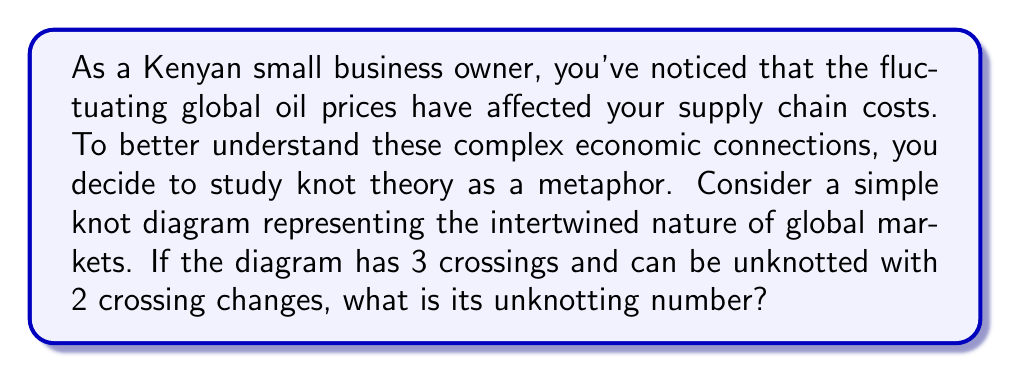Help me with this question. To solve this problem, we need to understand the concept of unknotting number and how it relates to the given knot diagram. Let's break it down step-by-step:

1. Definition of unknotting number:
   The unknotting number of a knot is the minimum number of crossing changes required to transform the knot into an unknot (trivial knot).

2. Given information:
   - The knot diagram has 3 crossings
   - It can be unknotted with 2 crossing changes

3. Analysis:
   - The unknotting number is always less than or equal to the number of crossings in the diagram.
   - In this case, we are told that 2 crossing changes are sufficient to unknot the diagram.
   - The question asks for the unknotting number, which is the minimum number of crossing changes needed.

4. Conclusion:
   Since we know that 2 crossing changes are sufficient to unknot the diagram, and we're looking for the minimum number, the unknotting number must be less than or equal to 2.

   Given that the knot is not trivial (it has 3 crossings), the unknotting number cannot be 0.

   If the unknotting number were 1, it would mean that changing just one crossing would unknot the diagram. However, we're told that 2 changes are needed.

   Therefore, the unknotting number of this knot diagram is 2.

This can be represented mathematically as:

$$u(K) = 2$$

Where $u(K)$ denotes the unknotting number of the knot $K$.
Answer: 2 